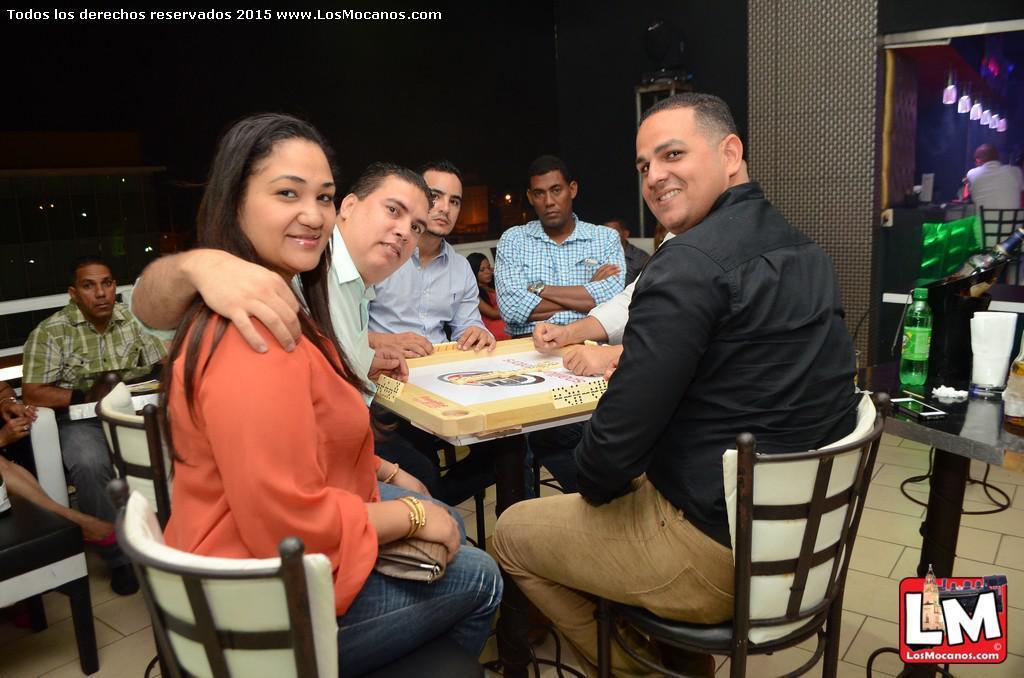How would you summarize this image in a sentence or two? In this image we can see sitting on the chairs and tables are placed in between them. On the tables we can see board game, disposal bottle, cell phone, paper napkin and glass tumbler. 